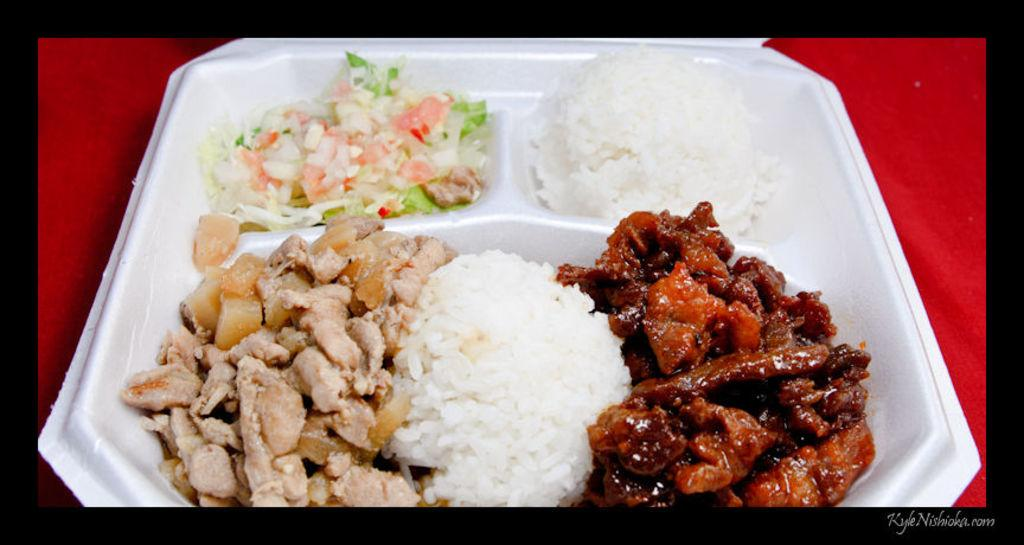What is on the plate in the image? There are food items on a plate in the image. What color is the background of the image? The background of the image has a red color. Is there any text visible in the image? Yes, there is some text in the bottom right corner of the image. Can you see any cherries on the plate in the image? There is no information about cherries being present on the plate in the image. Is there a squirrel swimming in the background of the image? There is no squirrel or swimming activity depicted in the image; the background has a red color. 